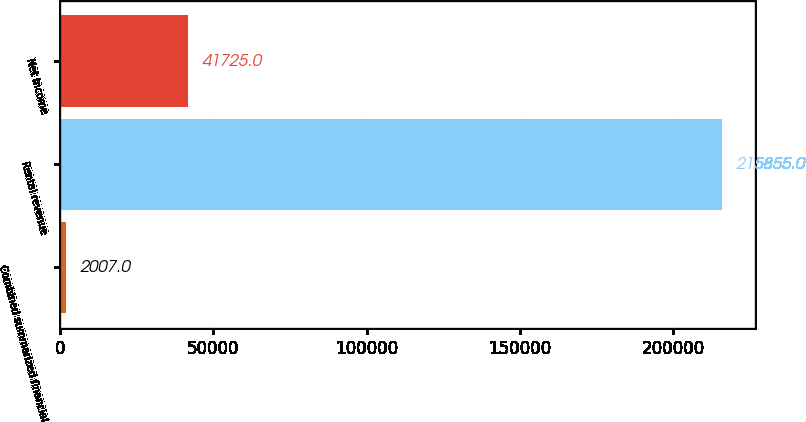Convert chart to OTSL. <chart><loc_0><loc_0><loc_500><loc_500><bar_chart><fcel>Combined summarized financial<fcel>Rental revenue<fcel>Net income<nl><fcel>2007<fcel>215855<fcel>41725<nl></chart> 